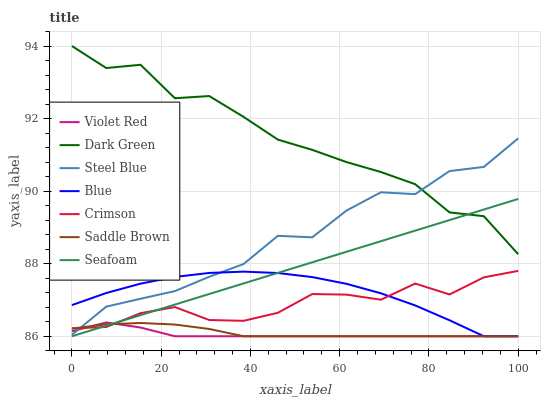Does Violet Red have the minimum area under the curve?
Answer yes or no. Yes. Does Dark Green have the maximum area under the curve?
Answer yes or no. Yes. Does Steel Blue have the minimum area under the curve?
Answer yes or no. No. Does Steel Blue have the maximum area under the curve?
Answer yes or no. No. Is Seafoam the smoothest?
Answer yes or no. Yes. Is Dark Green the roughest?
Answer yes or no. Yes. Is Violet Red the smoothest?
Answer yes or no. No. Is Violet Red the roughest?
Answer yes or no. No. Does Blue have the lowest value?
Answer yes or no. Yes. Does Steel Blue have the lowest value?
Answer yes or no. No. Does Dark Green have the highest value?
Answer yes or no. Yes. Does Violet Red have the highest value?
Answer yes or no. No. Is Blue less than Dark Green?
Answer yes or no. Yes. Is Dark Green greater than Crimson?
Answer yes or no. Yes. Does Saddle Brown intersect Violet Red?
Answer yes or no. Yes. Is Saddle Brown less than Violet Red?
Answer yes or no. No. Is Saddle Brown greater than Violet Red?
Answer yes or no. No. Does Blue intersect Dark Green?
Answer yes or no. No. 